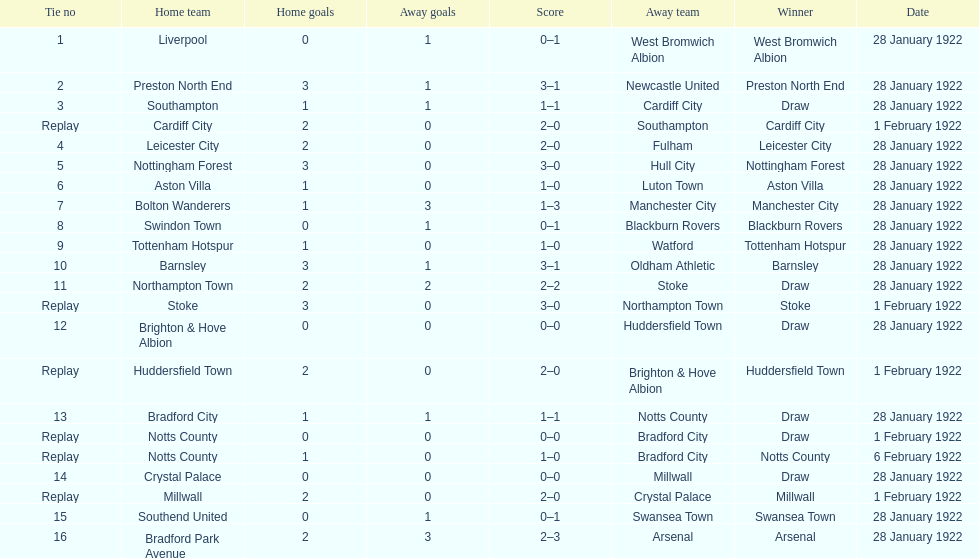How many total points were scored in the second round proper? 45. 